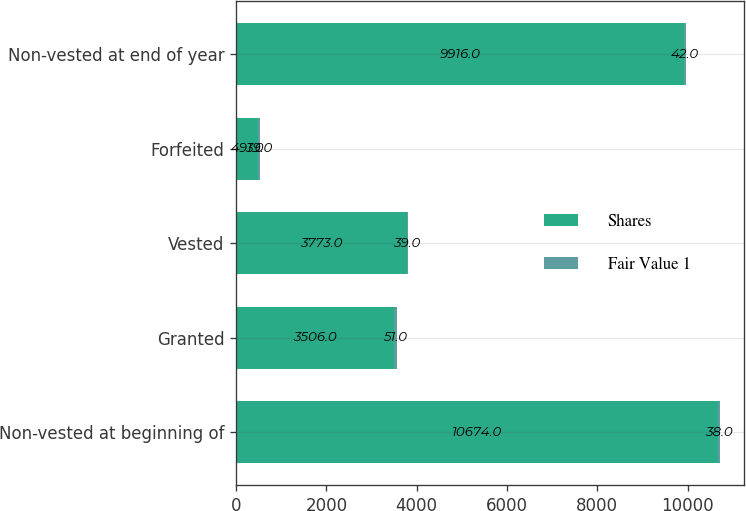<chart> <loc_0><loc_0><loc_500><loc_500><stacked_bar_chart><ecel><fcel>Non-vested at beginning of<fcel>Granted<fcel>Vested<fcel>Forfeited<fcel>Non-vested at end of year<nl><fcel>Shares<fcel>10674<fcel>3506<fcel>3773<fcel>491<fcel>9916<nl><fcel>Fair Value 1<fcel>38<fcel>51<fcel>39<fcel>39<fcel>42<nl></chart> 